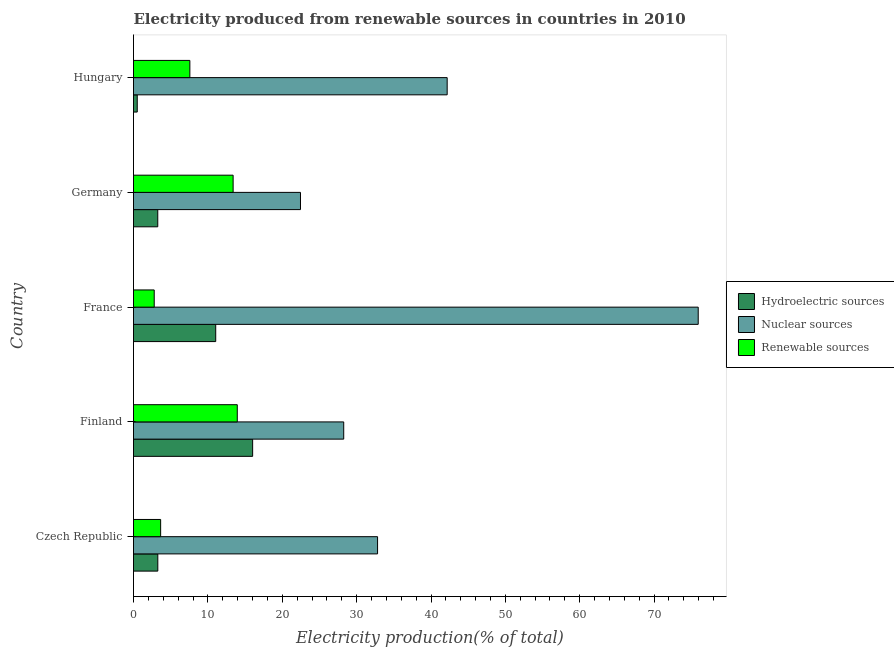How many groups of bars are there?
Ensure brevity in your answer.  5. Are the number of bars on each tick of the Y-axis equal?
Your response must be concise. Yes. How many bars are there on the 3rd tick from the bottom?
Your response must be concise. 3. What is the label of the 3rd group of bars from the top?
Give a very brief answer. France. In how many cases, is the number of bars for a given country not equal to the number of legend labels?
Give a very brief answer. 0. What is the percentage of electricity produced by hydroelectric sources in Finland?
Provide a succinct answer. 16.02. Across all countries, what is the maximum percentage of electricity produced by renewable sources?
Your response must be concise. 13.95. Across all countries, what is the minimum percentage of electricity produced by hydroelectric sources?
Offer a terse response. 0.5. What is the total percentage of electricity produced by renewable sources in the graph?
Make the answer very short. 41.36. What is the difference between the percentage of electricity produced by hydroelectric sources in Czech Republic and that in France?
Ensure brevity in your answer.  -7.79. What is the difference between the percentage of electricity produced by hydroelectric sources in Hungary and the percentage of electricity produced by renewable sources in Germany?
Provide a short and direct response. -12.89. What is the average percentage of electricity produced by renewable sources per country?
Your answer should be very brief. 8.27. What is the difference between the percentage of electricity produced by renewable sources and percentage of electricity produced by nuclear sources in Finland?
Ensure brevity in your answer.  -14.31. In how many countries, is the percentage of electricity produced by hydroelectric sources greater than 68 %?
Your answer should be compact. 0. What is the ratio of the percentage of electricity produced by hydroelectric sources in Czech Republic to that in Finland?
Give a very brief answer. 0.2. Is the difference between the percentage of electricity produced by renewable sources in Finland and Hungary greater than the difference between the percentage of electricity produced by hydroelectric sources in Finland and Hungary?
Offer a very short reply. No. What is the difference between the highest and the second highest percentage of electricity produced by hydroelectric sources?
Your answer should be very brief. 4.96. What is the difference between the highest and the lowest percentage of electricity produced by nuclear sources?
Give a very brief answer. 53.48. In how many countries, is the percentage of electricity produced by hydroelectric sources greater than the average percentage of electricity produced by hydroelectric sources taken over all countries?
Offer a terse response. 2. Is the sum of the percentage of electricity produced by renewable sources in Finland and Germany greater than the maximum percentage of electricity produced by nuclear sources across all countries?
Offer a very short reply. No. What does the 3rd bar from the top in Finland represents?
Offer a very short reply. Hydroelectric sources. What does the 2nd bar from the bottom in Hungary represents?
Your answer should be very brief. Nuclear sources. Is it the case that in every country, the sum of the percentage of electricity produced by hydroelectric sources and percentage of electricity produced by nuclear sources is greater than the percentage of electricity produced by renewable sources?
Your answer should be compact. Yes. How many bars are there?
Ensure brevity in your answer.  15. Are all the bars in the graph horizontal?
Give a very brief answer. Yes. How many countries are there in the graph?
Provide a short and direct response. 5. What is the difference between two consecutive major ticks on the X-axis?
Ensure brevity in your answer.  10. Are the values on the major ticks of X-axis written in scientific E-notation?
Your response must be concise. No. Does the graph contain grids?
Your response must be concise. No. Where does the legend appear in the graph?
Give a very brief answer. Center right. How many legend labels are there?
Offer a very short reply. 3. What is the title of the graph?
Provide a succinct answer. Electricity produced from renewable sources in countries in 2010. What is the label or title of the Y-axis?
Ensure brevity in your answer.  Country. What is the Electricity production(% of total) in Hydroelectric sources in Czech Republic?
Offer a terse response. 3.27. What is the Electricity production(% of total) of Nuclear sources in Czech Republic?
Provide a succinct answer. 32.82. What is the Electricity production(% of total) of Renewable sources in Czech Republic?
Keep it short and to the point. 3.65. What is the Electricity production(% of total) in Hydroelectric sources in Finland?
Offer a very short reply. 16.02. What is the Electricity production(% of total) of Nuclear sources in Finland?
Provide a short and direct response. 28.26. What is the Electricity production(% of total) of Renewable sources in Finland?
Your response must be concise. 13.95. What is the Electricity production(% of total) in Hydroelectric sources in France?
Ensure brevity in your answer.  11.05. What is the Electricity production(% of total) of Nuclear sources in France?
Your answer should be compact. 75.93. What is the Electricity production(% of total) of Renewable sources in France?
Your answer should be compact. 2.78. What is the Electricity production(% of total) of Hydroelectric sources in Germany?
Your answer should be very brief. 3.26. What is the Electricity production(% of total) in Nuclear sources in Germany?
Your answer should be compact. 22.45. What is the Electricity production(% of total) of Renewable sources in Germany?
Make the answer very short. 13.39. What is the Electricity production(% of total) in Hydroelectric sources in Hungary?
Offer a terse response. 0.5. What is the Electricity production(% of total) of Nuclear sources in Hungary?
Provide a succinct answer. 42.17. What is the Electricity production(% of total) in Renewable sources in Hungary?
Offer a very short reply. 7.58. Across all countries, what is the maximum Electricity production(% of total) of Hydroelectric sources?
Make the answer very short. 16.02. Across all countries, what is the maximum Electricity production(% of total) in Nuclear sources?
Your response must be concise. 75.93. Across all countries, what is the maximum Electricity production(% of total) of Renewable sources?
Provide a succinct answer. 13.95. Across all countries, what is the minimum Electricity production(% of total) of Hydroelectric sources?
Your response must be concise. 0.5. Across all countries, what is the minimum Electricity production(% of total) of Nuclear sources?
Your answer should be compact. 22.45. Across all countries, what is the minimum Electricity production(% of total) in Renewable sources?
Your response must be concise. 2.78. What is the total Electricity production(% of total) of Hydroelectric sources in the graph?
Your response must be concise. 34.11. What is the total Electricity production(% of total) in Nuclear sources in the graph?
Keep it short and to the point. 201.64. What is the total Electricity production(% of total) of Renewable sources in the graph?
Ensure brevity in your answer.  41.36. What is the difference between the Electricity production(% of total) of Hydroelectric sources in Czech Republic and that in Finland?
Your response must be concise. -12.75. What is the difference between the Electricity production(% of total) of Nuclear sources in Czech Republic and that in Finland?
Give a very brief answer. 4.55. What is the difference between the Electricity production(% of total) of Renewable sources in Czech Republic and that in Finland?
Your answer should be very brief. -10.3. What is the difference between the Electricity production(% of total) of Hydroelectric sources in Czech Republic and that in France?
Keep it short and to the point. -7.79. What is the difference between the Electricity production(% of total) of Nuclear sources in Czech Republic and that in France?
Ensure brevity in your answer.  -43.12. What is the difference between the Electricity production(% of total) of Renewable sources in Czech Republic and that in France?
Offer a terse response. 0.86. What is the difference between the Electricity production(% of total) in Hydroelectric sources in Czech Republic and that in Germany?
Offer a terse response. 0.01. What is the difference between the Electricity production(% of total) of Nuclear sources in Czech Republic and that in Germany?
Provide a succinct answer. 10.36. What is the difference between the Electricity production(% of total) of Renewable sources in Czech Republic and that in Germany?
Keep it short and to the point. -9.75. What is the difference between the Electricity production(% of total) of Hydroelectric sources in Czech Republic and that in Hungary?
Keep it short and to the point. 2.77. What is the difference between the Electricity production(% of total) of Nuclear sources in Czech Republic and that in Hungary?
Provide a short and direct response. -9.36. What is the difference between the Electricity production(% of total) of Renewable sources in Czech Republic and that in Hungary?
Provide a succinct answer. -3.93. What is the difference between the Electricity production(% of total) of Hydroelectric sources in Finland and that in France?
Provide a succinct answer. 4.96. What is the difference between the Electricity production(% of total) of Nuclear sources in Finland and that in France?
Your answer should be compact. -47.67. What is the difference between the Electricity production(% of total) in Renewable sources in Finland and that in France?
Ensure brevity in your answer.  11.17. What is the difference between the Electricity production(% of total) of Hydroelectric sources in Finland and that in Germany?
Provide a succinct answer. 12.76. What is the difference between the Electricity production(% of total) of Nuclear sources in Finland and that in Germany?
Your answer should be very brief. 5.81. What is the difference between the Electricity production(% of total) in Renewable sources in Finland and that in Germany?
Ensure brevity in your answer.  0.56. What is the difference between the Electricity production(% of total) of Hydroelectric sources in Finland and that in Hungary?
Provide a succinct answer. 15.52. What is the difference between the Electricity production(% of total) of Nuclear sources in Finland and that in Hungary?
Offer a very short reply. -13.91. What is the difference between the Electricity production(% of total) in Renewable sources in Finland and that in Hungary?
Make the answer very short. 6.38. What is the difference between the Electricity production(% of total) in Hydroelectric sources in France and that in Germany?
Provide a succinct answer. 7.79. What is the difference between the Electricity production(% of total) of Nuclear sources in France and that in Germany?
Give a very brief answer. 53.48. What is the difference between the Electricity production(% of total) of Renewable sources in France and that in Germany?
Make the answer very short. -10.61. What is the difference between the Electricity production(% of total) of Hydroelectric sources in France and that in Hungary?
Offer a terse response. 10.55. What is the difference between the Electricity production(% of total) in Nuclear sources in France and that in Hungary?
Your answer should be very brief. 33.76. What is the difference between the Electricity production(% of total) in Renewable sources in France and that in Hungary?
Give a very brief answer. -4.79. What is the difference between the Electricity production(% of total) in Hydroelectric sources in Germany and that in Hungary?
Provide a short and direct response. 2.76. What is the difference between the Electricity production(% of total) of Nuclear sources in Germany and that in Hungary?
Offer a terse response. -19.72. What is the difference between the Electricity production(% of total) of Renewable sources in Germany and that in Hungary?
Ensure brevity in your answer.  5.82. What is the difference between the Electricity production(% of total) of Hydroelectric sources in Czech Republic and the Electricity production(% of total) of Nuclear sources in Finland?
Give a very brief answer. -25. What is the difference between the Electricity production(% of total) in Hydroelectric sources in Czech Republic and the Electricity production(% of total) in Renewable sources in Finland?
Give a very brief answer. -10.68. What is the difference between the Electricity production(% of total) in Nuclear sources in Czech Republic and the Electricity production(% of total) in Renewable sources in Finland?
Offer a very short reply. 18.86. What is the difference between the Electricity production(% of total) in Hydroelectric sources in Czech Republic and the Electricity production(% of total) in Nuclear sources in France?
Give a very brief answer. -72.66. What is the difference between the Electricity production(% of total) of Hydroelectric sources in Czech Republic and the Electricity production(% of total) of Renewable sources in France?
Make the answer very short. 0.48. What is the difference between the Electricity production(% of total) of Nuclear sources in Czech Republic and the Electricity production(% of total) of Renewable sources in France?
Your answer should be very brief. 30.03. What is the difference between the Electricity production(% of total) in Hydroelectric sources in Czech Republic and the Electricity production(% of total) in Nuclear sources in Germany?
Ensure brevity in your answer.  -19.18. What is the difference between the Electricity production(% of total) in Hydroelectric sources in Czech Republic and the Electricity production(% of total) in Renewable sources in Germany?
Ensure brevity in your answer.  -10.13. What is the difference between the Electricity production(% of total) in Nuclear sources in Czech Republic and the Electricity production(% of total) in Renewable sources in Germany?
Offer a very short reply. 19.42. What is the difference between the Electricity production(% of total) of Hydroelectric sources in Czech Republic and the Electricity production(% of total) of Nuclear sources in Hungary?
Your answer should be very brief. -38.91. What is the difference between the Electricity production(% of total) in Hydroelectric sources in Czech Republic and the Electricity production(% of total) in Renewable sources in Hungary?
Ensure brevity in your answer.  -4.31. What is the difference between the Electricity production(% of total) in Nuclear sources in Czech Republic and the Electricity production(% of total) in Renewable sources in Hungary?
Provide a short and direct response. 25.24. What is the difference between the Electricity production(% of total) of Hydroelectric sources in Finland and the Electricity production(% of total) of Nuclear sources in France?
Keep it short and to the point. -59.91. What is the difference between the Electricity production(% of total) of Hydroelectric sources in Finland and the Electricity production(% of total) of Renewable sources in France?
Provide a succinct answer. 13.23. What is the difference between the Electricity production(% of total) in Nuclear sources in Finland and the Electricity production(% of total) in Renewable sources in France?
Offer a terse response. 25.48. What is the difference between the Electricity production(% of total) of Hydroelectric sources in Finland and the Electricity production(% of total) of Nuclear sources in Germany?
Offer a very short reply. -6.43. What is the difference between the Electricity production(% of total) in Hydroelectric sources in Finland and the Electricity production(% of total) in Renewable sources in Germany?
Make the answer very short. 2.62. What is the difference between the Electricity production(% of total) of Nuclear sources in Finland and the Electricity production(% of total) of Renewable sources in Germany?
Provide a succinct answer. 14.87. What is the difference between the Electricity production(% of total) of Hydroelectric sources in Finland and the Electricity production(% of total) of Nuclear sources in Hungary?
Offer a very short reply. -26.16. What is the difference between the Electricity production(% of total) of Hydroelectric sources in Finland and the Electricity production(% of total) of Renewable sources in Hungary?
Keep it short and to the point. 8.44. What is the difference between the Electricity production(% of total) in Nuclear sources in Finland and the Electricity production(% of total) in Renewable sources in Hungary?
Your response must be concise. 20.69. What is the difference between the Electricity production(% of total) in Hydroelectric sources in France and the Electricity production(% of total) in Nuclear sources in Germany?
Ensure brevity in your answer.  -11.4. What is the difference between the Electricity production(% of total) of Hydroelectric sources in France and the Electricity production(% of total) of Renewable sources in Germany?
Your answer should be compact. -2.34. What is the difference between the Electricity production(% of total) in Nuclear sources in France and the Electricity production(% of total) in Renewable sources in Germany?
Keep it short and to the point. 62.54. What is the difference between the Electricity production(% of total) of Hydroelectric sources in France and the Electricity production(% of total) of Nuclear sources in Hungary?
Make the answer very short. -31.12. What is the difference between the Electricity production(% of total) of Hydroelectric sources in France and the Electricity production(% of total) of Renewable sources in Hungary?
Your response must be concise. 3.48. What is the difference between the Electricity production(% of total) in Nuclear sources in France and the Electricity production(% of total) in Renewable sources in Hungary?
Offer a very short reply. 68.35. What is the difference between the Electricity production(% of total) of Hydroelectric sources in Germany and the Electricity production(% of total) of Nuclear sources in Hungary?
Ensure brevity in your answer.  -38.91. What is the difference between the Electricity production(% of total) of Hydroelectric sources in Germany and the Electricity production(% of total) of Renewable sources in Hungary?
Ensure brevity in your answer.  -4.32. What is the difference between the Electricity production(% of total) of Nuclear sources in Germany and the Electricity production(% of total) of Renewable sources in Hungary?
Keep it short and to the point. 14.87. What is the average Electricity production(% of total) of Hydroelectric sources per country?
Make the answer very short. 6.82. What is the average Electricity production(% of total) in Nuclear sources per country?
Provide a succinct answer. 40.33. What is the average Electricity production(% of total) of Renewable sources per country?
Your answer should be compact. 8.27. What is the difference between the Electricity production(% of total) of Hydroelectric sources and Electricity production(% of total) of Nuclear sources in Czech Republic?
Ensure brevity in your answer.  -29.55. What is the difference between the Electricity production(% of total) of Hydroelectric sources and Electricity production(% of total) of Renewable sources in Czech Republic?
Provide a succinct answer. -0.38. What is the difference between the Electricity production(% of total) in Nuclear sources and Electricity production(% of total) in Renewable sources in Czech Republic?
Offer a very short reply. 29.17. What is the difference between the Electricity production(% of total) of Hydroelectric sources and Electricity production(% of total) of Nuclear sources in Finland?
Provide a short and direct response. -12.25. What is the difference between the Electricity production(% of total) of Hydroelectric sources and Electricity production(% of total) of Renewable sources in Finland?
Keep it short and to the point. 2.07. What is the difference between the Electricity production(% of total) in Nuclear sources and Electricity production(% of total) in Renewable sources in Finland?
Keep it short and to the point. 14.31. What is the difference between the Electricity production(% of total) in Hydroelectric sources and Electricity production(% of total) in Nuclear sources in France?
Provide a succinct answer. -64.88. What is the difference between the Electricity production(% of total) in Hydroelectric sources and Electricity production(% of total) in Renewable sources in France?
Offer a terse response. 8.27. What is the difference between the Electricity production(% of total) in Nuclear sources and Electricity production(% of total) in Renewable sources in France?
Ensure brevity in your answer.  73.15. What is the difference between the Electricity production(% of total) of Hydroelectric sources and Electricity production(% of total) of Nuclear sources in Germany?
Your answer should be compact. -19.19. What is the difference between the Electricity production(% of total) of Hydroelectric sources and Electricity production(% of total) of Renewable sources in Germany?
Your answer should be very brief. -10.13. What is the difference between the Electricity production(% of total) of Nuclear sources and Electricity production(% of total) of Renewable sources in Germany?
Make the answer very short. 9.06. What is the difference between the Electricity production(% of total) of Hydroelectric sources and Electricity production(% of total) of Nuclear sources in Hungary?
Ensure brevity in your answer.  -41.67. What is the difference between the Electricity production(% of total) of Hydroelectric sources and Electricity production(% of total) of Renewable sources in Hungary?
Make the answer very short. -7.08. What is the difference between the Electricity production(% of total) of Nuclear sources and Electricity production(% of total) of Renewable sources in Hungary?
Ensure brevity in your answer.  34.6. What is the ratio of the Electricity production(% of total) of Hydroelectric sources in Czech Republic to that in Finland?
Keep it short and to the point. 0.2. What is the ratio of the Electricity production(% of total) in Nuclear sources in Czech Republic to that in Finland?
Provide a succinct answer. 1.16. What is the ratio of the Electricity production(% of total) of Renewable sources in Czech Republic to that in Finland?
Provide a short and direct response. 0.26. What is the ratio of the Electricity production(% of total) in Hydroelectric sources in Czech Republic to that in France?
Offer a terse response. 0.3. What is the ratio of the Electricity production(% of total) in Nuclear sources in Czech Republic to that in France?
Offer a terse response. 0.43. What is the ratio of the Electricity production(% of total) in Renewable sources in Czech Republic to that in France?
Offer a terse response. 1.31. What is the ratio of the Electricity production(% of total) in Hydroelectric sources in Czech Republic to that in Germany?
Your response must be concise. 1. What is the ratio of the Electricity production(% of total) in Nuclear sources in Czech Republic to that in Germany?
Offer a terse response. 1.46. What is the ratio of the Electricity production(% of total) of Renewable sources in Czech Republic to that in Germany?
Offer a very short reply. 0.27. What is the ratio of the Electricity production(% of total) of Hydroelectric sources in Czech Republic to that in Hungary?
Offer a terse response. 6.5. What is the ratio of the Electricity production(% of total) in Nuclear sources in Czech Republic to that in Hungary?
Offer a very short reply. 0.78. What is the ratio of the Electricity production(% of total) in Renewable sources in Czech Republic to that in Hungary?
Ensure brevity in your answer.  0.48. What is the ratio of the Electricity production(% of total) of Hydroelectric sources in Finland to that in France?
Ensure brevity in your answer.  1.45. What is the ratio of the Electricity production(% of total) of Nuclear sources in Finland to that in France?
Offer a very short reply. 0.37. What is the ratio of the Electricity production(% of total) in Renewable sources in Finland to that in France?
Provide a short and direct response. 5.01. What is the ratio of the Electricity production(% of total) of Hydroelectric sources in Finland to that in Germany?
Give a very brief answer. 4.91. What is the ratio of the Electricity production(% of total) of Nuclear sources in Finland to that in Germany?
Your answer should be very brief. 1.26. What is the ratio of the Electricity production(% of total) of Renewable sources in Finland to that in Germany?
Provide a short and direct response. 1.04. What is the ratio of the Electricity production(% of total) in Hydroelectric sources in Finland to that in Hungary?
Keep it short and to the point. 31.84. What is the ratio of the Electricity production(% of total) of Nuclear sources in Finland to that in Hungary?
Make the answer very short. 0.67. What is the ratio of the Electricity production(% of total) of Renewable sources in Finland to that in Hungary?
Your answer should be very brief. 1.84. What is the ratio of the Electricity production(% of total) of Hydroelectric sources in France to that in Germany?
Your answer should be compact. 3.39. What is the ratio of the Electricity production(% of total) of Nuclear sources in France to that in Germany?
Keep it short and to the point. 3.38. What is the ratio of the Electricity production(% of total) in Renewable sources in France to that in Germany?
Your response must be concise. 0.21. What is the ratio of the Electricity production(% of total) in Hydroelectric sources in France to that in Hungary?
Keep it short and to the point. 21.97. What is the ratio of the Electricity production(% of total) in Nuclear sources in France to that in Hungary?
Make the answer very short. 1.8. What is the ratio of the Electricity production(% of total) of Renewable sources in France to that in Hungary?
Offer a very short reply. 0.37. What is the ratio of the Electricity production(% of total) in Hydroelectric sources in Germany to that in Hungary?
Your answer should be very brief. 6.48. What is the ratio of the Electricity production(% of total) in Nuclear sources in Germany to that in Hungary?
Offer a terse response. 0.53. What is the ratio of the Electricity production(% of total) of Renewable sources in Germany to that in Hungary?
Make the answer very short. 1.77. What is the difference between the highest and the second highest Electricity production(% of total) in Hydroelectric sources?
Your answer should be compact. 4.96. What is the difference between the highest and the second highest Electricity production(% of total) of Nuclear sources?
Your response must be concise. 33.76. What is the difference between the highest and the second highest Electricity production(% of total) of Renewable sources?
Your answer should be compact. 0.56. What is the difference between the highest and the lowest Electricity production(% of total) of Hydroelectric sources?
Give a very brief answer. 15.52. What is the difference between the highest and the lowest Electricity production(% of total) of Nuclear sources?
Your answer should be compact. 53.48. What is the difference between the highest and the lowest Electricity production(% of total) in Renewable sources?
Your answer should be compact. 11.17. 